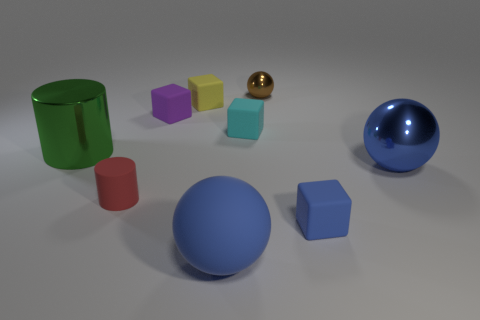Subtract all green cubes. Subtract all green cylinders. How many cubes are left? 4 Subtract all cubes. How many objects are left? 5 Add 7 tiny blue rubber cubes. How many tiny blue rubber cubes are left? 8 Add 4 small purple shiny cylinders. How many small purple shiny cylinders exist? 4 Subtract 0 yellow spheres. How many objects are left? 9 Subtract all tiny blue things. Subtract all tiny cubes. How many objects are left? 4 